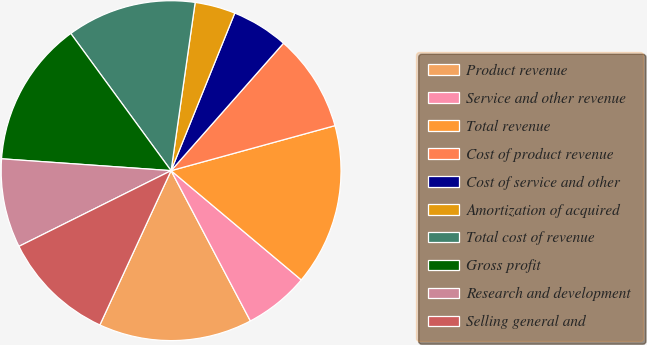Convert chart to OTSL. <chart><loc_0><loc_0><loc_500><loc_500><pie_chart><fcel>Product revenue<fcel>Service and other revenue<fcel>Total revenue<fcel>Cost of product revenue<fcel>Cost of service and other<fcel>Amortization of acquired<fcel>Total cost of revenue<fcel>Gross profit<fcel>Research and development<fcel>Selling general and<nl><fcel>14.61%<fcel>6.16%<fcel>15.38%<fcel>9.23%<fcel>5.39%<fcel>3.85%<fcel>12.31%<fcel>13.84%<fcel>8.46%<fcel>10.77%<nl></chart> 